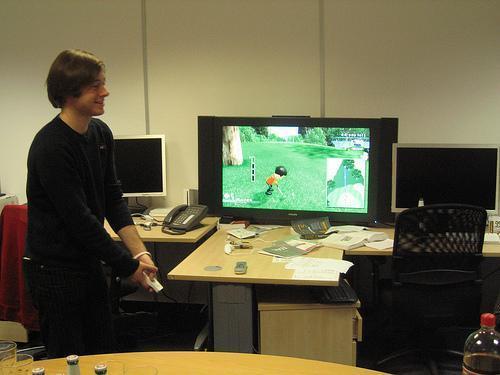How many people are showing?
Give a very brief answer. 1. How many screens are turned on?
Give a very brief answer. 1. 